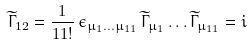<formula> <loc_0><loc_0><loc_500><loc_500>\widetilde { \Gamma } _ { 1 2 } = \frac { 1 } { 1 1 ! } \, \epsilon _ { \mu _ { 1 } \dots \mu _ { 1 1 } } \, \widetilde { \Gamma } _ { \mu _ { 1 } } \dots \widetilde { \Gamma } _ { \mu _ { 1 1 } } = i</formula> 